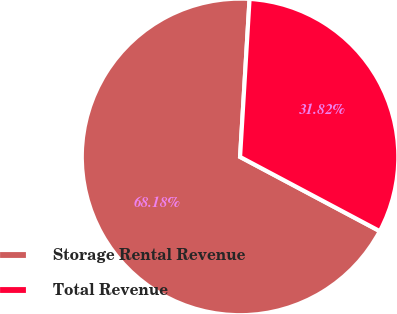Convert chart. <chart><loc_0><loc_0><loc_500><loc_500><pie_chart><fcel>Storage Rental Revenue<fcel>Total Revenue<nl><fcel>68.18%<fcel>31.82%<nl></chart> 